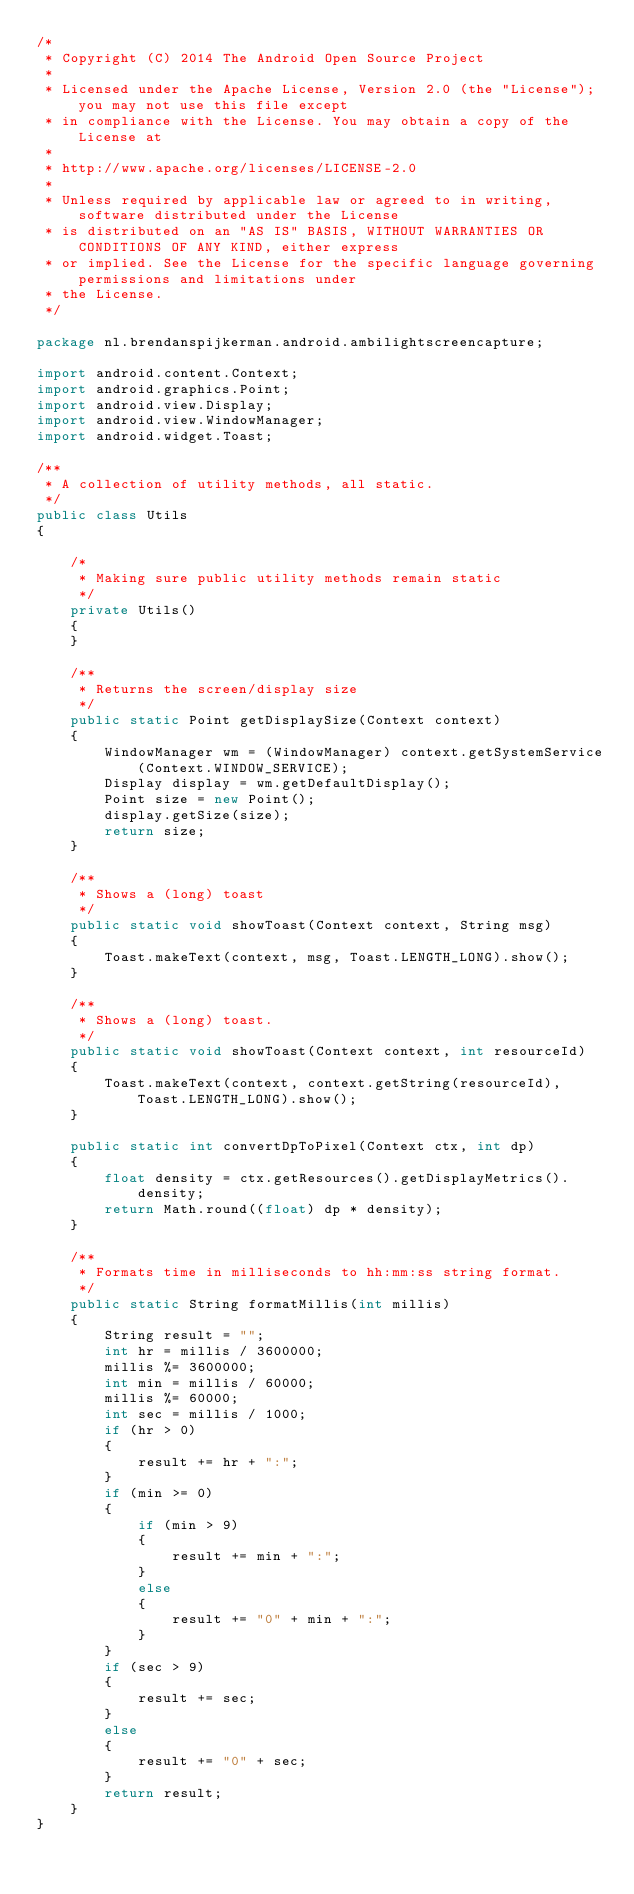Convert code to text. <code><loc_0><loc_0><loc_500><loc_500><_Java_>/*
 * Copyright (C) 2014 The Android Open Source Project
 *
 * Licensed under the Apache License, Version 2.0 (the "License"); you may not use this file except
 * in compliance with the License. You may obtain a copy of the License at
 *
 * http://www.apache.org/licenses/LICENSE-2.0
 *
 * Unless required by applicable law or agreed to in writing, software distributed under the License
 * is distributed on an "AS IS" BASIS, WITHOUT WARRANTIES OR CONDITIONS OF ANY KIND, either express
 * or implied. See the License for the specific language governing permissions and limitations under
 * the License.
 */

package nl.brendanspijkerman.android.ambilightscreencapture;

import android.content.Context;
import android.graphics.Point;
import android.view.Display;
import android.view.WindowManager;
import android.widget.Toast;

/**
 * A collection of utility methods, all static.
 */
public class Utils
{

    /*
     * Making sure public utility methods remain static
     */
    private Utils()
    {
    }

    /**
     * Returns the screen/display size
     */
    public static Point getDisplaySize(Context context)
    {
        WindowManager wm = (WindowManager) context.getSystemService(Context.WINDOW_SERVICE);
        Display display = wm.getDefaultDisplay();
        Point size = new Point();
        display.getSize(size);
        return size;
    }

    /**
     * Shows a (long) toast
     */
    public static void showToast(Context context, String msg)
    {
        Toast.makeText(context, msg, Toast.LENGTH_LONG).show();
    }

    /**
     * Shows a (long) toast.
     */
    public static void showToast(Context context, int resourceId)
    {
        Toast.makeText(context, context.getString(resourceId), Toast.LENGTH_LONG).show();
    }

    public static int convertDpToPixel(Context ctx, int dp)
    {
        float density = ctx.getResources().getDisplayMetrics().density;
        return Math.round((float) dp * density);
    }

    /**
     * Formats time in milliseconds to hh:mm:ss string format.
     */
    public static String formatMillis(int millis)
    {
        String result = "";
        int hr = millis / 3600000;
        millis %= 3600000;
        int min = millis / 60000;
        millis %= 60000;
        int sec = millis / 1000;
        if (hr > 0)
        {
            result += hr + ":";
        }
        if (min >= 0)
        {
            if (min > 9)
            {
                result += min + ":";
            }
            else
            {
                result += "0" + min + ":";
            }
        }
        if (sec > 9)
        {
            result += sec;
        }
        else
        {
            result += "0" + sec;
        }
        return result;
    }
}
</code> 